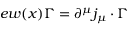Convert formula to latex. <formula><loc_0><loc_0><loc_500><loc_500>e w ( x ) \Gamma = \partial ^ { \mu } j _ { \mu } \cdot \Gamma</formula> 